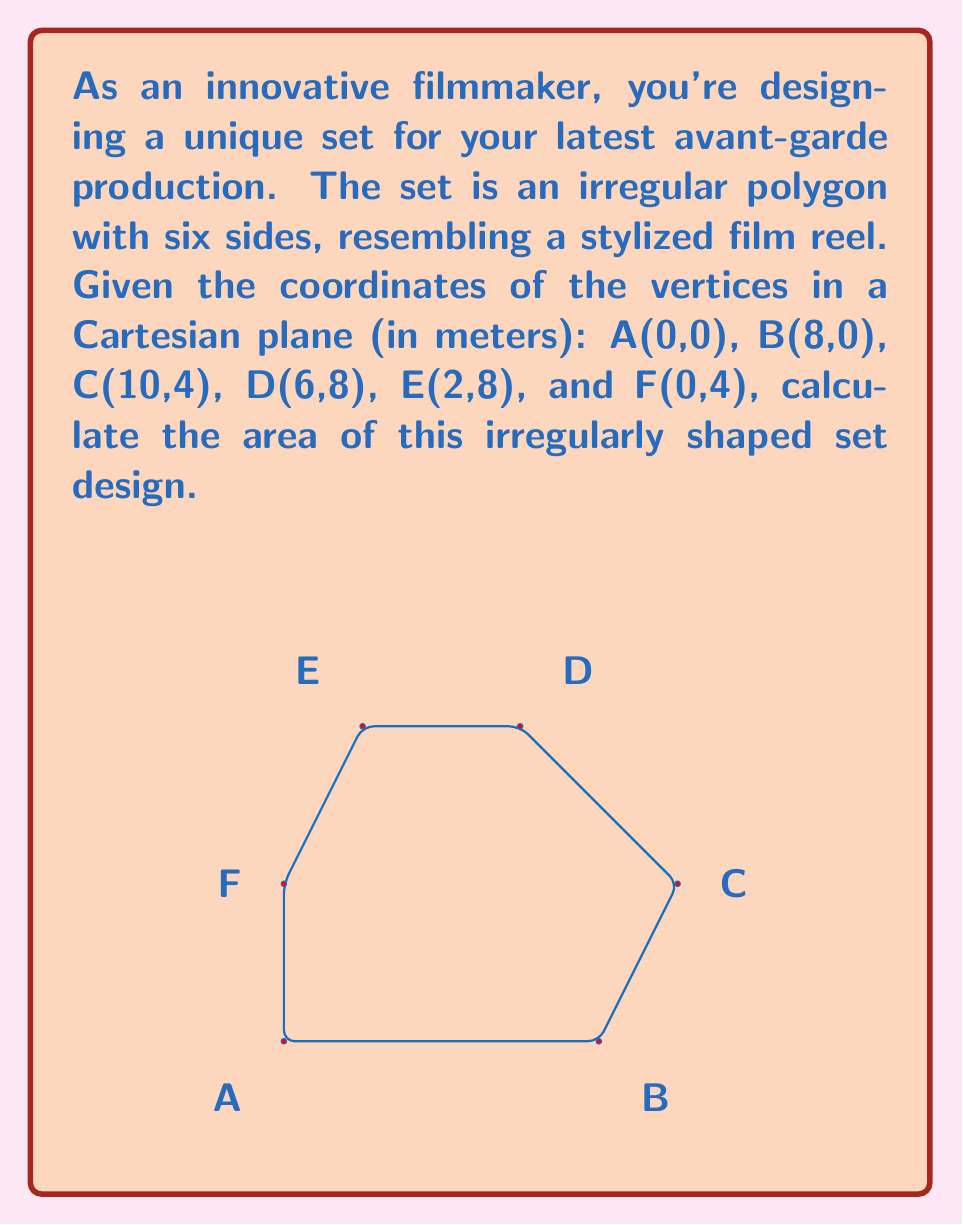Teach me how to tackle this problem. To solve this problem, we can use the Shoelace formula (also known as the surveyor's formula) to calculate the area of an irregular polygon given its vertices.

The Shoelace formula is:

$$ Area = \frac{1}{2}|\sum_{i=1}^{n-1} (x_iy_{i+1} + x_ny_1) - \sum_{i=1}^{n-1} (y_ix_{i+1} + y_nx_1)| $$

Where $(x_i, y_i)$ are the coordinates of the $i$-th vertex.

Let's apply this formula to our polygon:

1) First, let's list out our x and y coordinates in order:
   $(x_1,y_1) = (0,0)$, $(x_2,y_2) = (8,0)$, $(x_3,y_3) = (10,4)$, 
   $(x_4,y_4) = (6,8)$, $(x_5,y_5) = (2,8)$, $(x_6,y_6) = (0,4)$

2) Now, let's calculate the first sum:
   $\sum_{i=1}^{n-1} (x_iy_{i+1} + x_ny_1) = (0 \cdot 0) + (8 \cdot 4) + (10 \cdot 8) + (6 \cdot 8) + (2 \cdot 4) + (0 \cdot 0) = 32 + 80 + 48 + 8 = 168$

3) Next, let's calculate the second sum:
   $\sum_{i=1}^{n-1} (y_ix_{i+1} + y_nx_1) = (0 \cdot 8) + (0 \cdot 10) + (4 \cdot 6) + (8 \cdot 2) + (8 \cdot 0) + (4 \cdot 0) = 24 + 16 = 40$

4) Now we can subtract and take the absolute value:
   $|168 - 40| = 128$

5) Finally, we divide by 2:
   $\frac{128}{2} = 64$

Therefore, the area of the irregularly shaped set design is 64 square meters.
Answer: The area of the irregularly shaped set design is 64 m². 